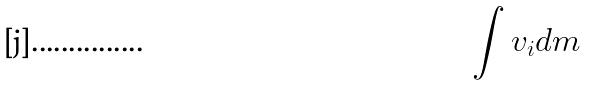<formula> <loc_0><loc_0><loc_500><loc_500>\int v _ { i } d m</formula> 